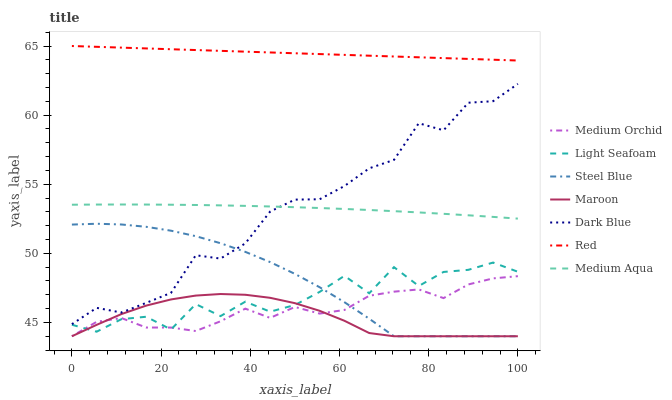Does Maroon have the minimum area under the curve?
Answer yes or no. Yes. Does Red have the maximum area under the curve?
Answer yes or no. Yes. Does Steel Blue have the minimum area under the curve?
Answer yes or no. No. Does Steel Blue have the maximum area under the curve?
Answer yes or no. No. Is Red the smoothest?
Answer yes or no. Yes. Is Light Seafoam the roughest?
Answer yes or no. Yes. Is Steel Blue the smoothest?
Answer yes or no. No. Is Steel Blue the roughest?
Answer yes or no. No. Does Medium Orchid have the lowest value?
Answer yes or no. Yes. Does Dark Blue have the lowest value?
Answer yes or no. No. Does Red have the highest value?
Answer yes or no. Yes. Does Steel Blue have the highest value?
Answer yes or no. No. Is Medium Aqua less than Red?
Answer yes or no. Yes. Is Medium Aqua greater than Maroon?
Answer yes or no. Yes. Does Medium Orchid intersect Maroon?
Answer yes or no. Yes. Is Medium Orchid less than Maroon?
Answer yes or no. No. Is Medium Orchid greater than Maroon?
Answer yes or no. No. Does Medium Aqua intersect Red?
Answer yes or no. No. 